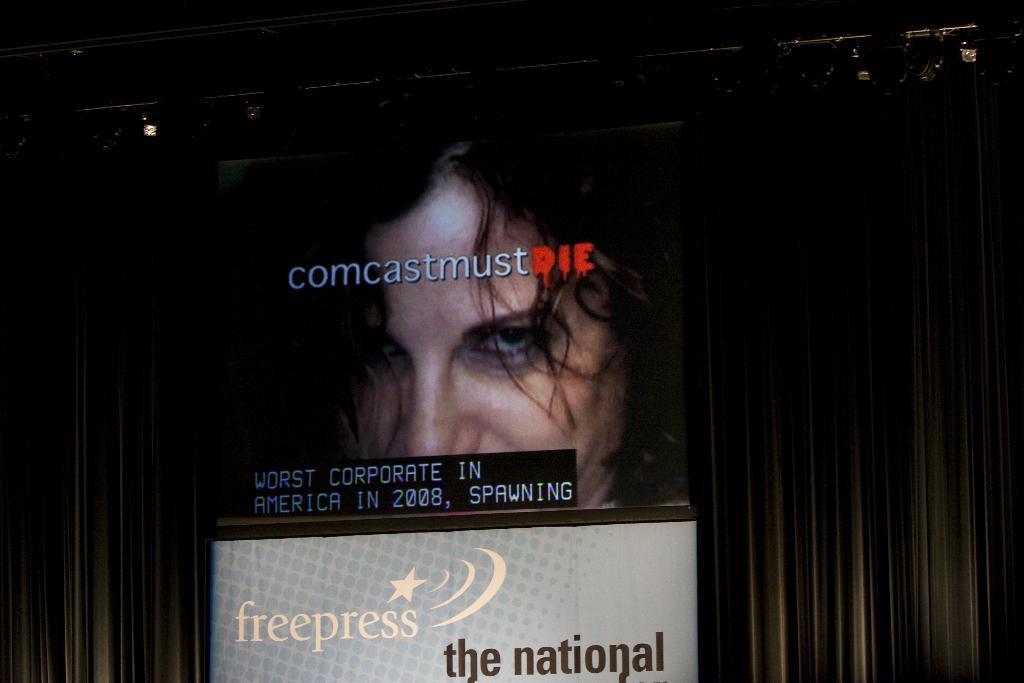Describe this image in one or two sentences. In this image, we can see some boards with text and images. We can see the background and some objects at the top. 